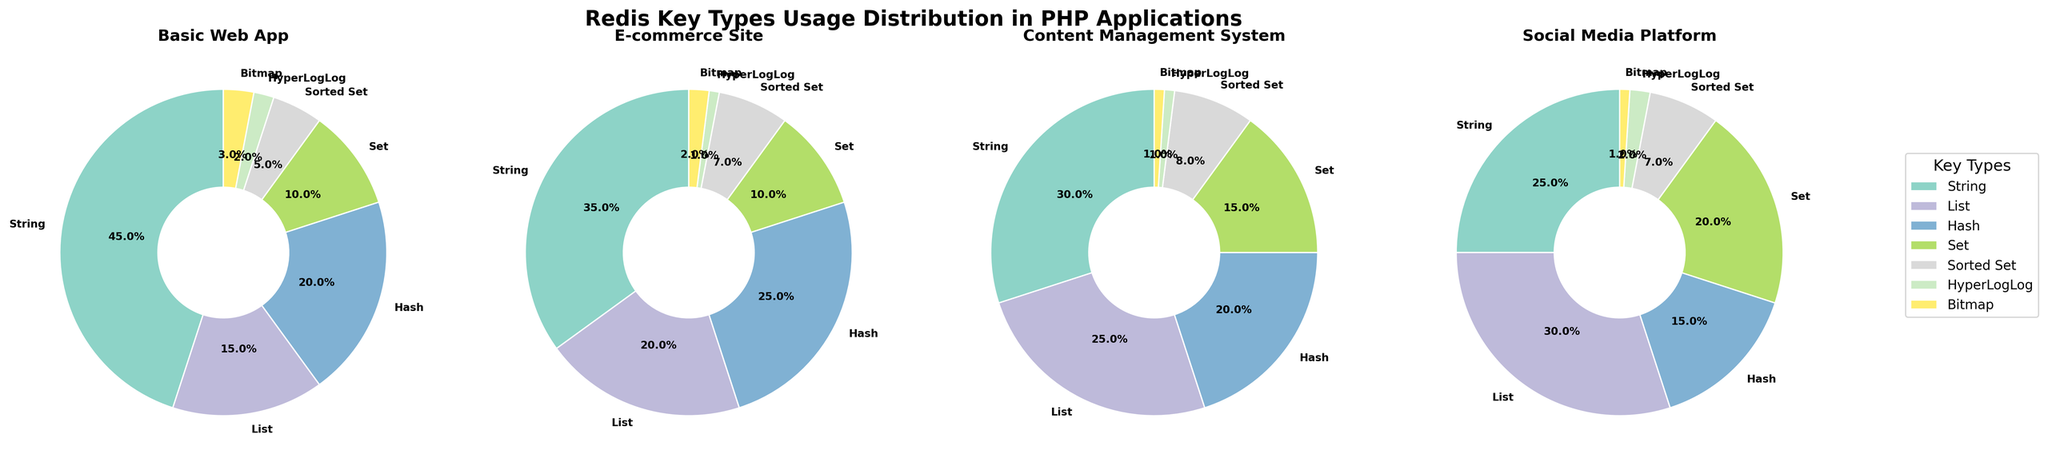What is the most used Redis key type in the Basic Web App? The Basic Web App slice with the largest percentage in the pie chart represents the most used key type. In the Basic Web App pie chart, the largest slice is for 'String'.
Answer: String Which PHP application uses the 'List' Redis key type the most? Compare the 'List' slices across all four pie charts. The Social Media Platform slice is the largest for 'List'.
Answer: Social Media Platform What is the combined percentage of 'Set' and 'Sorted Set' keys in the Content Management System? Identify 'Set' and 'Sorted Set' percentages in the Content Management System pie chart: 'Set' is 15% and 'Sorted Set' is 8%. Their combined percentage is 15 + 8.
Answer: 23% Which application type has the highest diversity in key types usage? Diversity can be interpreted as the most even distribution across key types. By comparing all four pie charts, each should have relatively equal-sized slices; the Social Media Platform appears to have a more evenly spread distribution among its slices.
Answer: Social Media Platform Are there any key types that are not used in any PHP applications listed? Each application pie chart has no slices omitted, which means every key type is represented with at least one slice in each chart.
Answer: No What is the least used key type in the E-commerce Site? The smallest slice in the E-commerce Site pie chart represents the least used key type. 'Bitmap' has the smallest slice in the E-commerce Site.
Answer: Bitmap Compare the usage of 'Hash' key types between E-commerce Site and Social Media Platform. Which uses it more? The 'Hash' key slices in the E-commerce Site and Social Media Platform pie charts show 25% and 15%, respectively. The E-commerce Site has a larger 'Hash' usage.
Answer: E-commerce Site What percentage of usage does 'HyperLogLog' comprise in the Basic Web App relative to 'Bitmap' in the same app? The 'HyperLogLog' is 2% and 'Bitmap' is 3% in the Basic Web App. To find relative usage, (HyperLogLog/Bitmap)*100 = (2/3)*100 = 66.67%.
Answer: 66.67% Is there any significant visual difference in the use of 'Sorted Set' across all application types? Examine the 'Sorted Set' slices in all pie charts: Basic Web App (5%), E-commerce (7%), CMS (8%), and Social Media Platform (7%). There is no dramatic variation across applications; the usage is fairly consistent.
Answer: No significant difference Which two key types have exactly the same percentage usage in the Basic Web App? In the Basic Web App pie chart, 'Set' and 'Hash' have the same usage percentage, both shown as 20%.
Answer: Set and Hash 